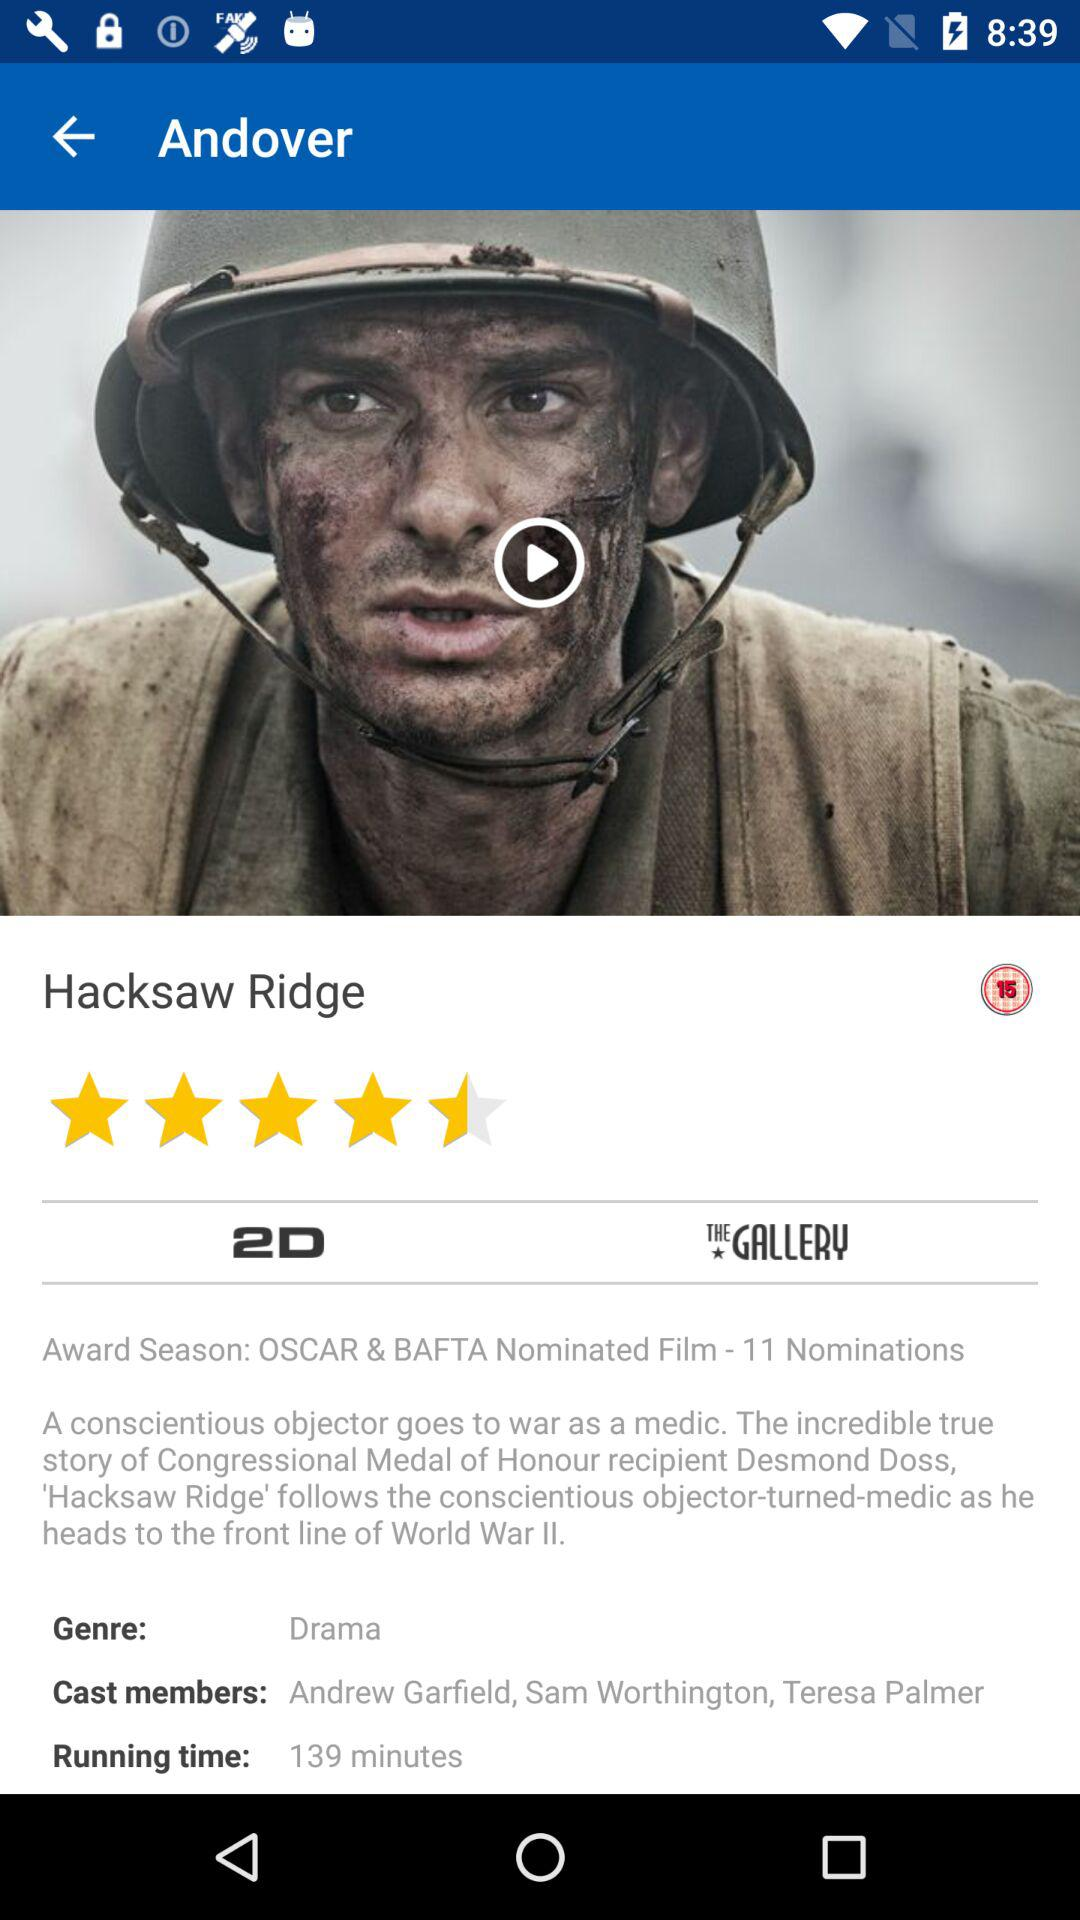What is the running time? The running time is 139 minutes. 